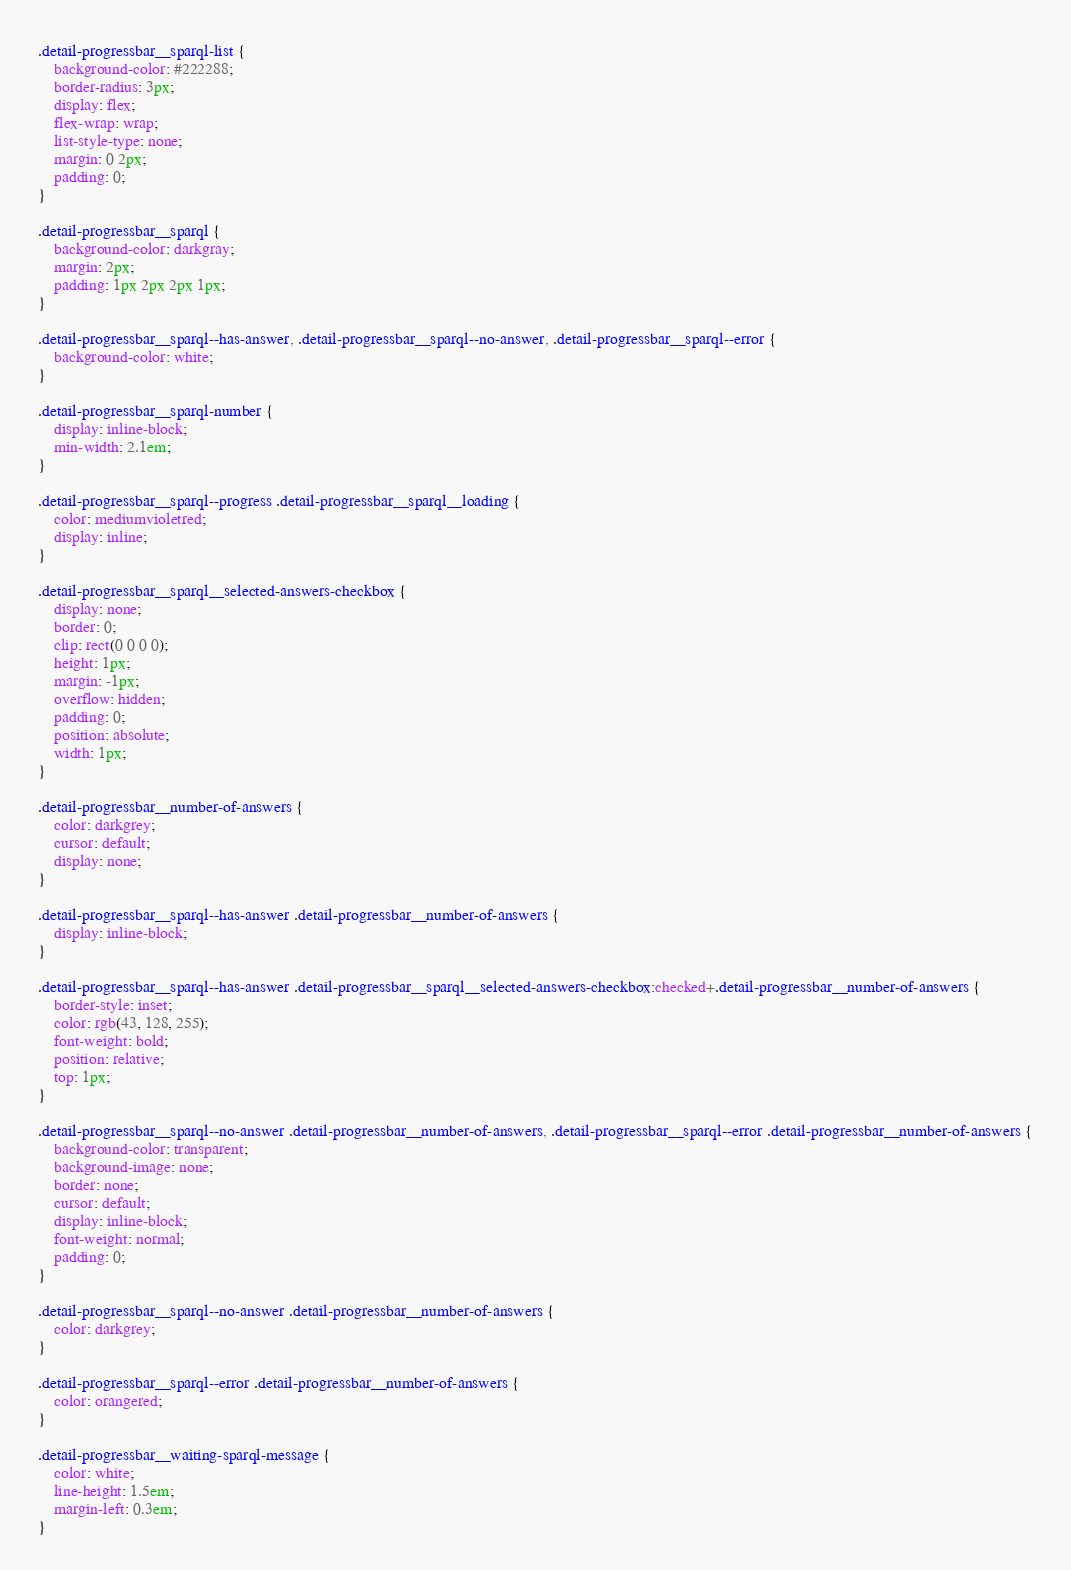<code> <loc_0><loc_0><loc_500><loc_500><_CSS_>.detail-progressbar__sparql-list {
    background-color: #222288;
    border-radius: 3px;
    display: flex;
    flex-wrap: wrap;
    list-style-type: none;
    margin: 0 2px;
    padding: 0;
}

.detail-progressbar__sparql {
    background-color: darkgray;
    margin: 2px;
    padding: 1px 2px 2px 1px;
}

.detail-progressbar__sparql--has-answer, .detail-progressbar__sparql--no-answer, .detail-progressbar__sparql--error {
    background-color: white;
}

.detail-progressbar__sparql-number {
    display: inline-block;
    min-width: 2.1em;
}

.detail-progressbar__sparql--progress .detail-progressbar__sparql__loading {
    color: mediumvioletred;
    display: inline;
}

.detail-progressbar__sparql__selected-answers-checkbox {
    display: none;
    border: 0;
    clip: rect(0 0 0 0);
    height: 1px;
    margin: -1px;
    overflow: hidden;
    padding: 0;
    position: absolute;
    width: 1px;
}

.detail-progressbar__number-of-answers {
    color: darkgrey;
    cursor: default;
    display: none;
}

.detail-progressbar__sparql--has-answer .detail-progressbar__number-of-answers {
    display: inline-block;
}

.detail-progressbar__sparql--has-answer .detail-progressbar__sparql__selected-answers-checkbox:checked+.detail-progressbar__number-of-answers {
    border-style: inset;
    color: rgb(43, 128, 255);
    font-weight: bold;
    position: relative;
    top: 1px;
}

.detail-progressbar__sparql--no-answer .detail-progressbar__number-of-answers, .detail-progressbar__sparql--error .detail-progressbar__number-of-answers {
    background-color: transparent;
    background-image: none;
    border: none;
    cursor: default;
    display: inline-block;
    font-weight: normal;
    padding: 0;
}

.detail-progressbar__sparql--no-answer .detail-progressbar__number-of-answers {
    color: darkgrey;
}

.detail-progressbar__sparql--error .detail-progressbar__number-of-answers {
    color: orangered;
}

.detail-progressbar__waiting-sparql-message {
    color: white;
    line-height: 1.5em;
    margin-left: 0.3em;
}
</code> 